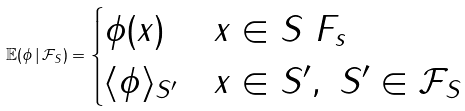<formula> <loc_0><loc_0><loc_500><loc_500>\mathbb { E } ( \phi \, | \, \mathcal { F } _ { S } ) = \begin{cases} \phi ( x ) & x \in S \ F _ { s } \\ \langle \phi \rangle _ { S ^ { \prime } } & x \in S ^ { \prime } , \ S ^ { \prime } \in \mathcal { F } _ { S } \end{cases}</formula> 